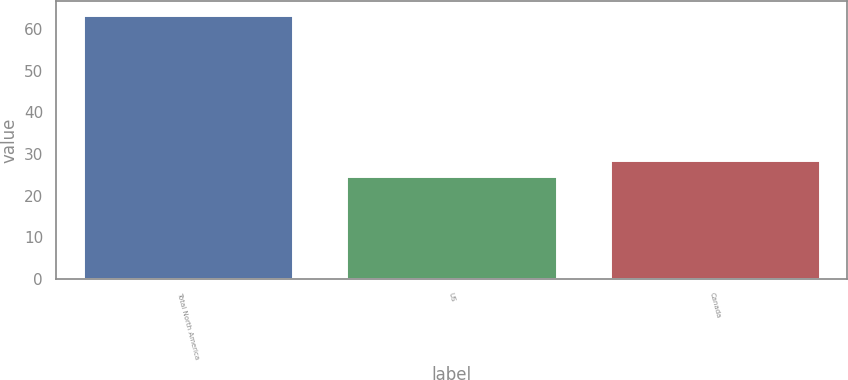Convert chart. <chart><loc_0><loc_0><loc_500><loc_500><bar_chart><fcel>Total North America<fcel>US<fcel>Canada<nl><fcel>63.5<fcel>24.6<fcel>28.49<nl></chart> 